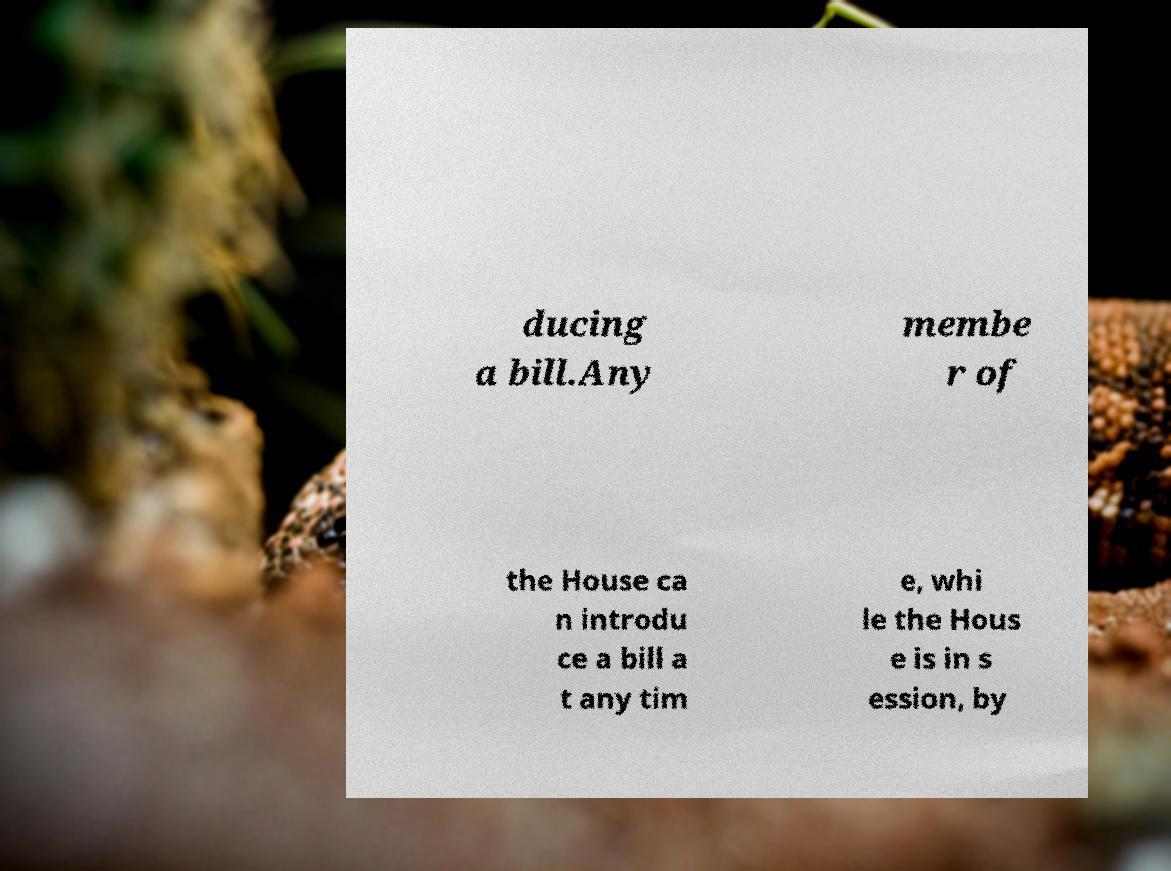I need the written content from this picture converted into text. Can you do that? ducing a bill.Any membe r of the House ca n introdu ce a bill a t any tim e, whi le the Hous e is in s ession, by 